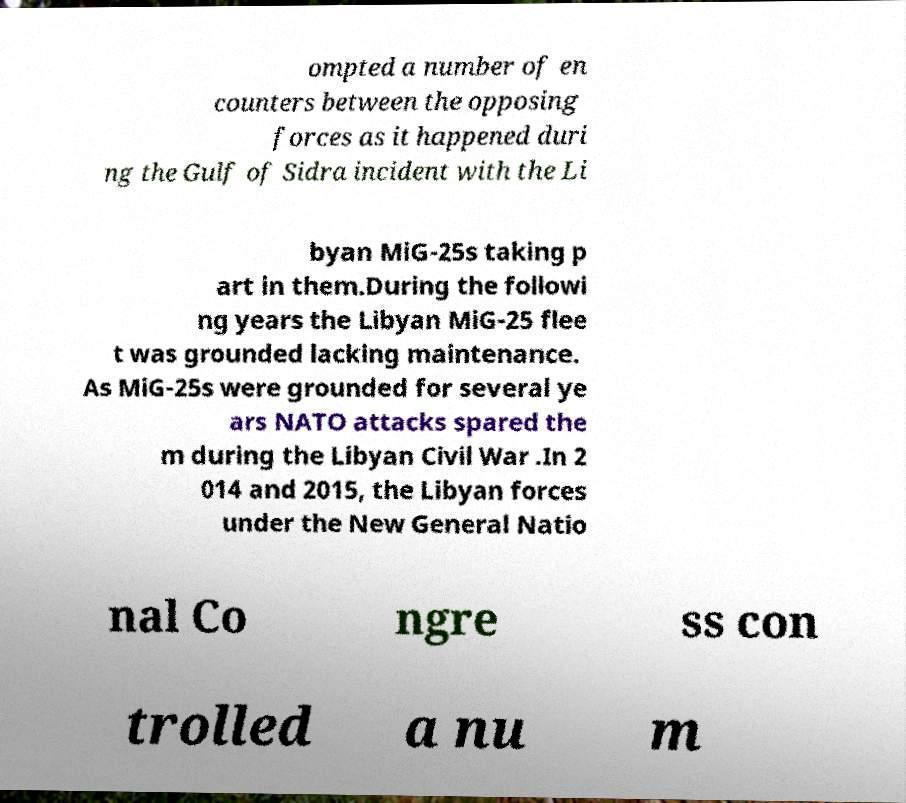There's text embedded in this image that I need extracted. Can you transcribe it verbatim? ompted a number of en counters between the opposing forces as it happened duri ng the Gulf of Sidra incident with the Li byan MiG-25s taking p art in them.During the followi ng years the Libyan MiG-25 flee t was grounded lacking maintenance. As MiG-25s were grounded for several ye ars NATO attacks spared the m during the Libyan Civil War .In 2 014 and 2015, the Libyan forces under the New General Natio nal Co ngre ss con trolled a nu m 